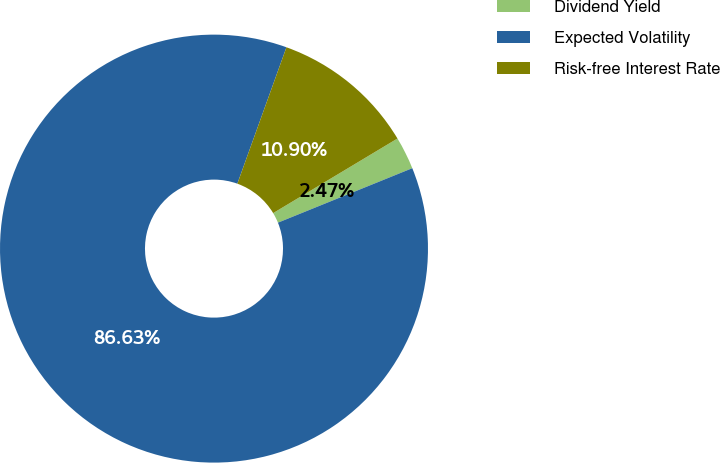<chart> <loc_0><loc_0><loc_500><loc_500><pie_chart><fcel>Dividend Yield<fcel>Expected Volatility<fcel>Risk-free Interest Rate<nl><fcel>2.47%<fcel>86.63%<fcel>10.9%<nl></chart> 